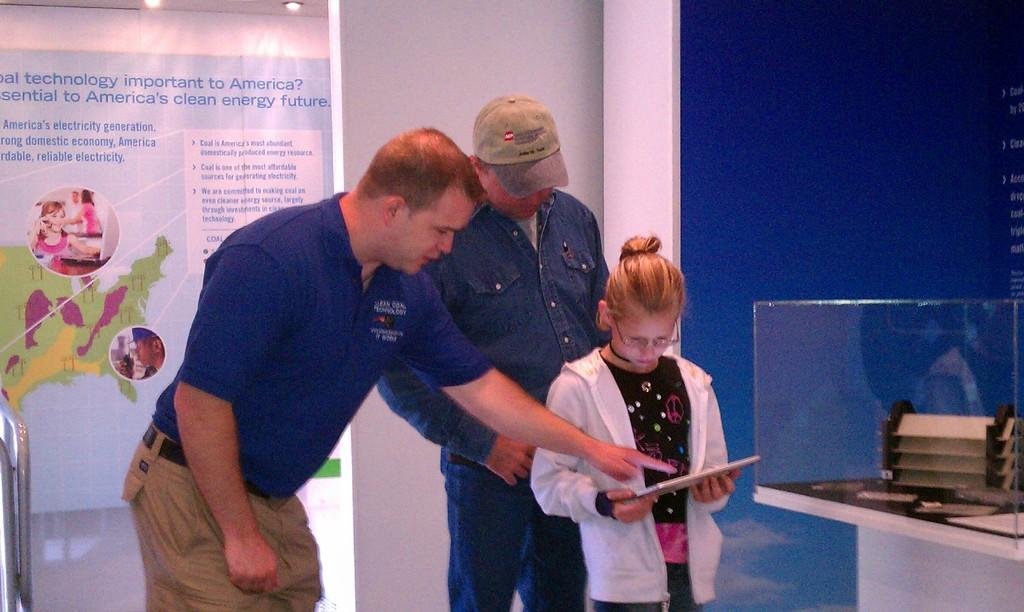Provide a one-sentence caption for the provided image. A man wearing a blue shirt with "coal technology" on the upper left side, points to a book a girl is reading.. 